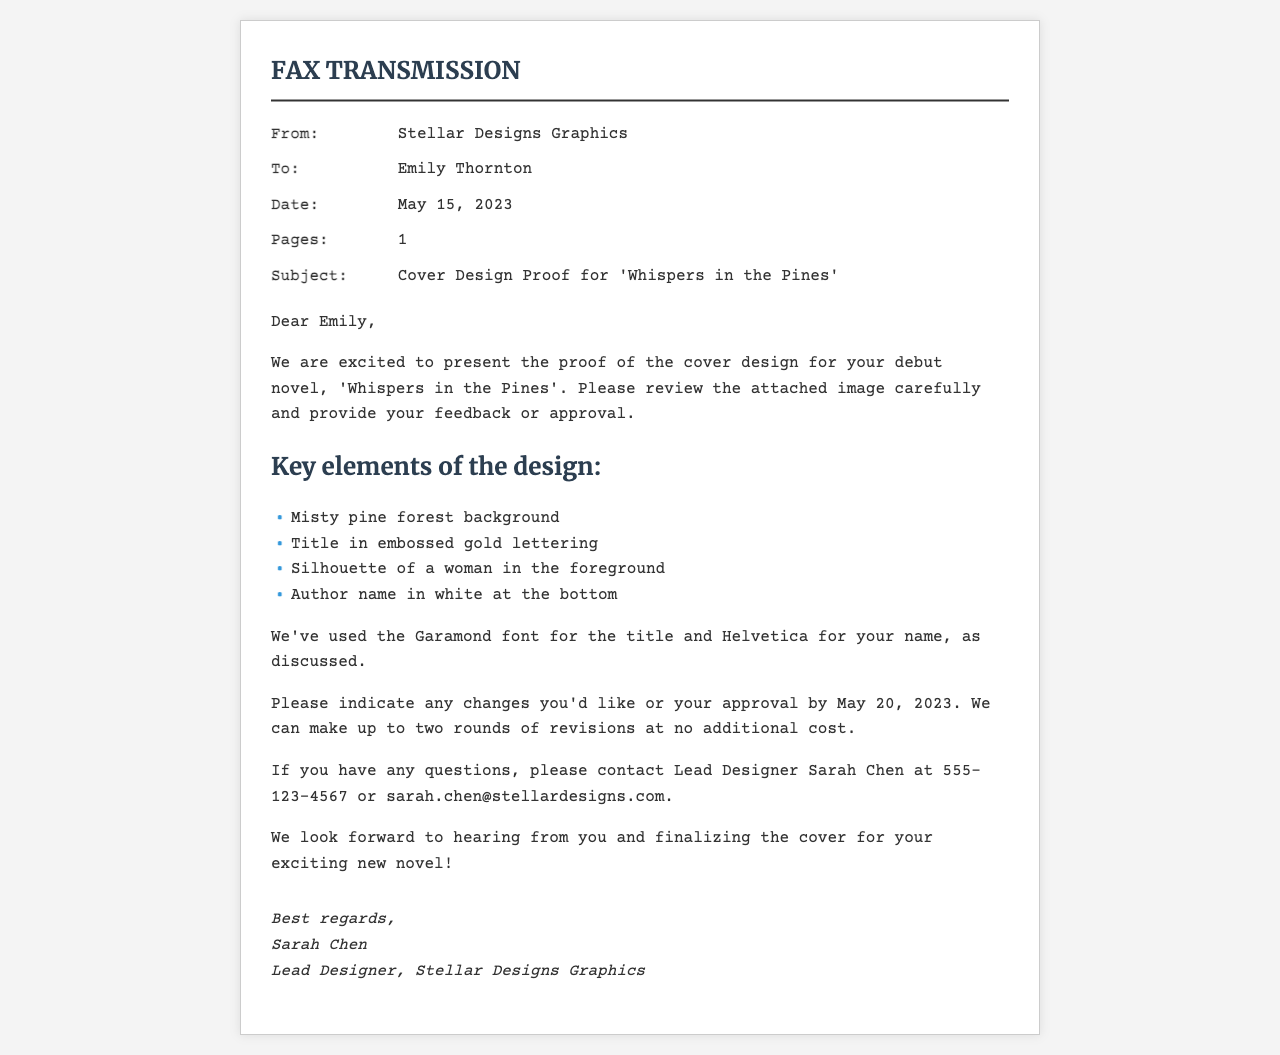What is the name of the graphic designer? The designer's name is mentioned in the signature at the end of the document.
Answer: Sarah Chen When was the fax sent? The date is specified in the fax's metadata section.
Answer: May 15, 2023 What is the title of the novel? The title is stated in the subject line and content of the fax.
Answer: Whispers in the Pines How many pages is the fax? The number of pages is indicated in the fax's metadata section.
Answer: 1 What is the deadline for feedback? The deadline for providing feedback is mentioned in the content of the fax.
Answer: May 20, 2023 What font is used for the title? The font for the title is specified in the content section.
Answer: Garamond How many rounds of revisions are allowed at no additional cost? The document mentions the limit of revisions in the content section.
Answer: Two What color is the author's name on the cover? The color of the author's name is described in the list of key design elements.
Answer: White Who should be contacted for questions about the cover design? The point of contact for inquiries is specified in the content section.
Answer: Sarah Chen What type of background is featured in the cover design? The background description is included in the list of key design elements.
Answer: Misty pine forest background 